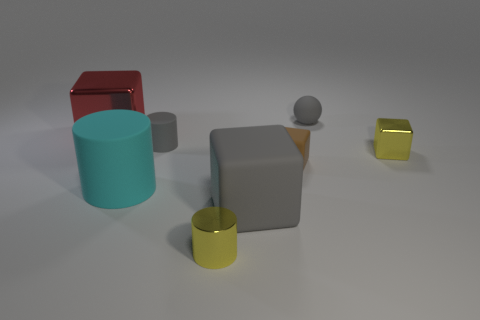Subtract all green cubes. Subtract all cyan cylinders. How many cubes are left? 4 Add 1 small yellow metal blocks. How many objects exist? 9 Subtract all balls. How many objects are left? 7 Add 3 large red cubes. How many large red cubes are left? 4 Add 7 red things. How many red things exist? 8 Subtract 1 gray spheres. How many objects are left? 7 Subtract all large gray metal blocks. Subtract all small gray cylinders. How many objects are left? 7 